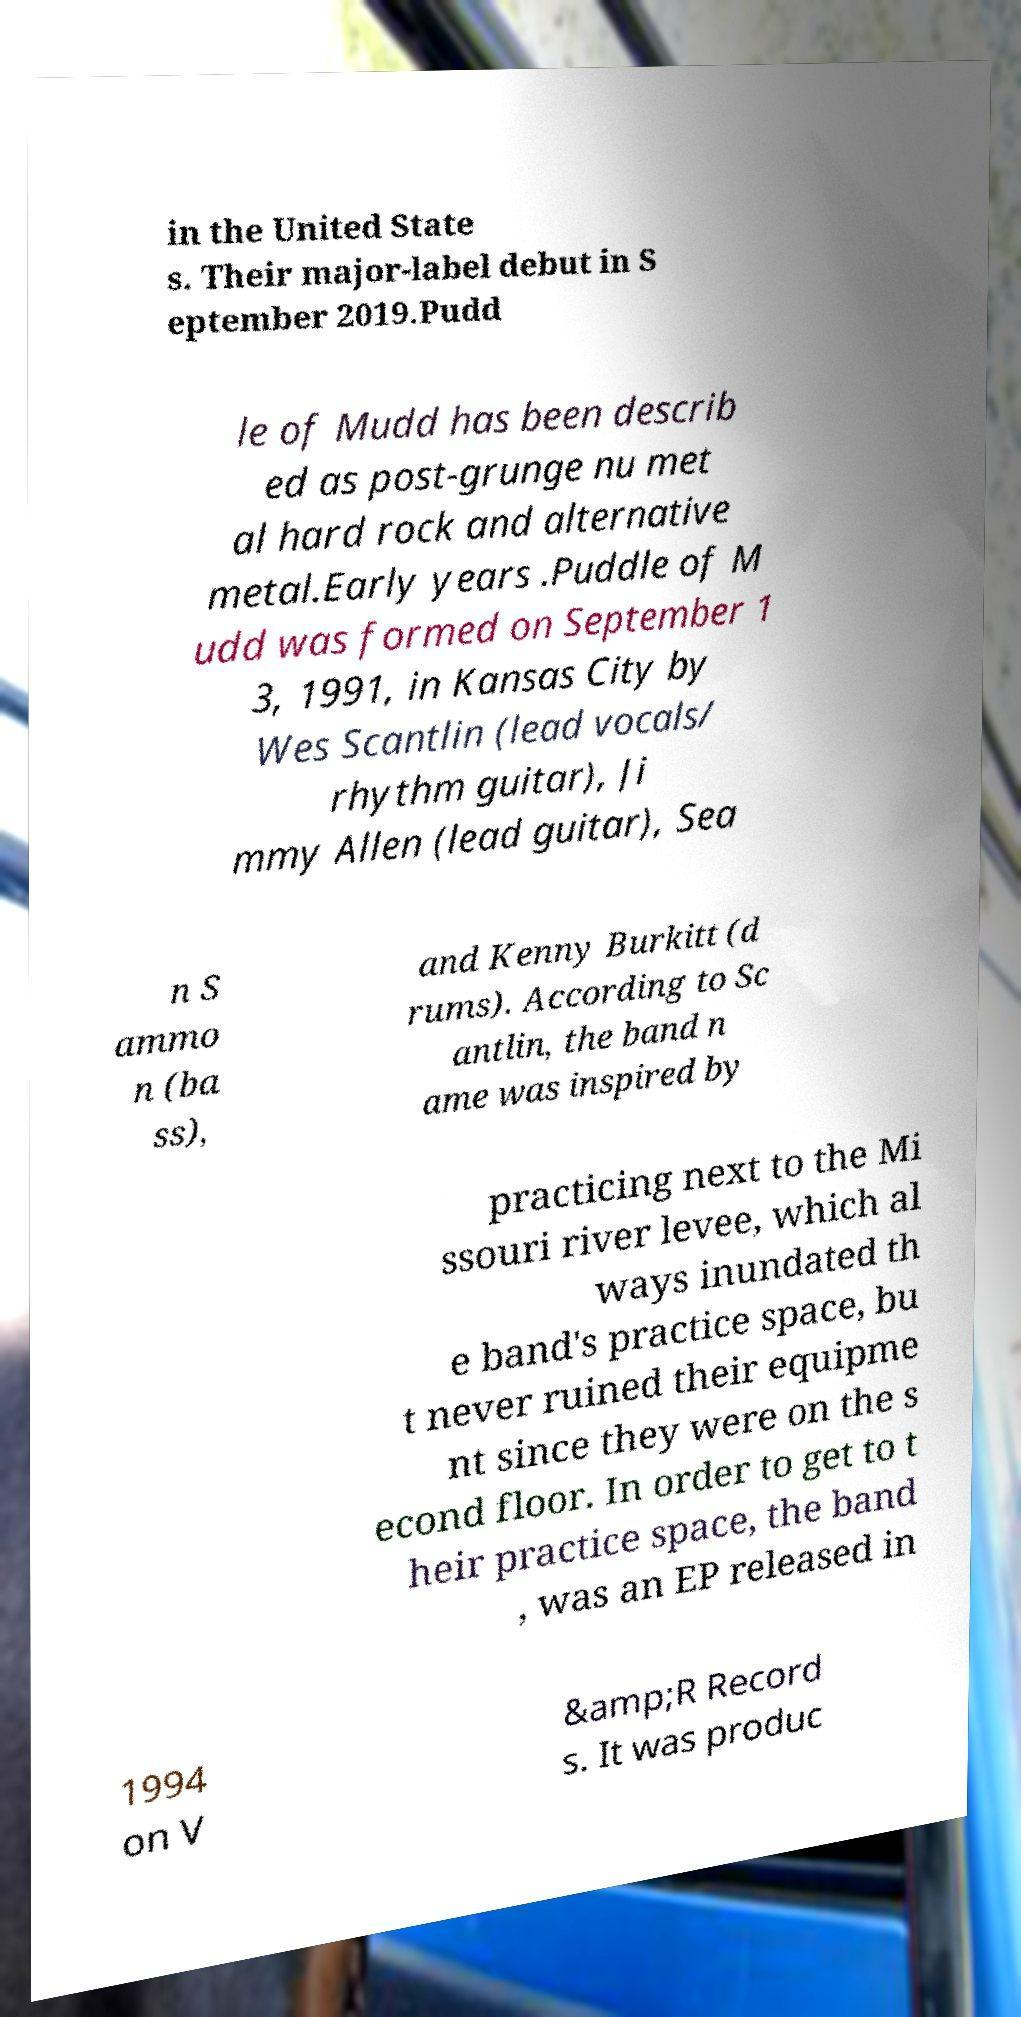Please read and relay the text visible in this image. What does it say? in the United State s. Their major-label debut in S eptember 2019.Pudd le of Mudd has been describ ed as post-grunge nu met al hard rock and alternative metal.Early years .Puddle of M udd was formed on September 1 3, 1991, in Kansas City by Wes Scantlin (lead vocals/ rhythm guitar), Ji mmy Allen (lead guitar), Sea n S ammo n (ba ss), and Kenny Burkitt (d rums). According to Sc antlin, the band n ame was inspired by practicing next to the Mi ssouri river levee, which al ways inundated th e band's practice space, bu t never ruined their equipme nt since they were on the s econd floor. In order to get to t heir practice space, the band , was an EP released in 1994 on V &amp;R Record s. It was produc 